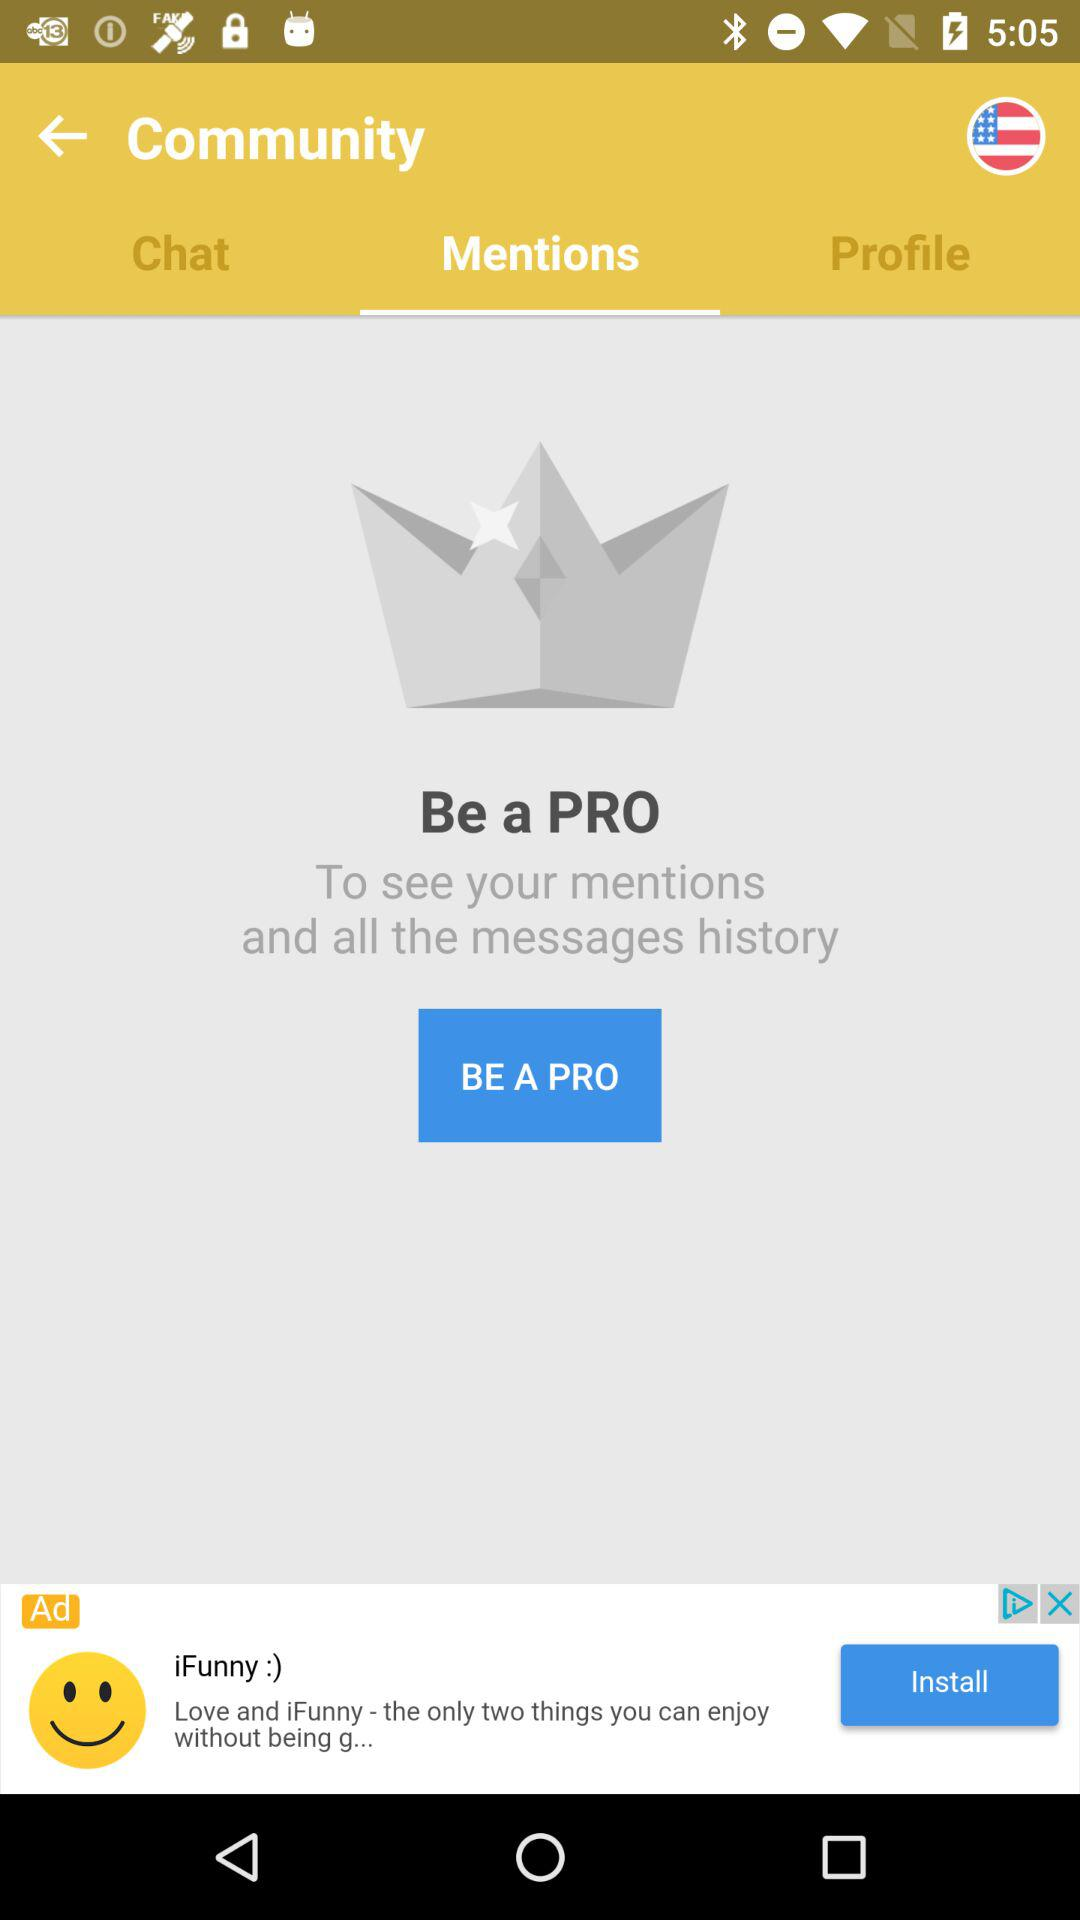What is the selected tab? The selected tab is "Mentions". 